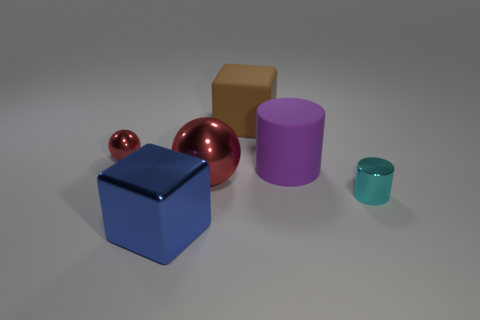What is the color of the metal object that is on the right side of the tiny red metal ball and behind the cyan object?
Your response must be concise. Red. What number of other objects are there of the same shape as the small red shiny object?
Keep it short and to the point. 1. Does the big sphere that is right of the blue metal cube have the same color as the tiny metal object that is on the left side of the purple thing?
Your answer should be compact. Yes. There is a shiny object right of the big ball; is its size the same as the purple rubber thing behind the tiny cyan object?
Give a very brief answer. No. Is there anything else that has the same material as the big cylinder?
Your answer should be compact. Yes. What material is the tiny object that is behind the small thing that is on the right side of the big blue metallic cube that is in front of the cyan metal object made of?
Your response must be concise. Metal. Is the shape of the big brown rubber thing the same as the large blue thing?
Ensure brevity in your answer.  Yes. There is a big brown thing that is the same shape as the blue object; what is its material?
Your answer should be compact. Rubber. What number of other shiny balls have the same color as the large shiny sphere?
Offer a terse response. 1. The brown block that is made of the same material as the big cylinder is what size?
Offer a very short reply. Large. 